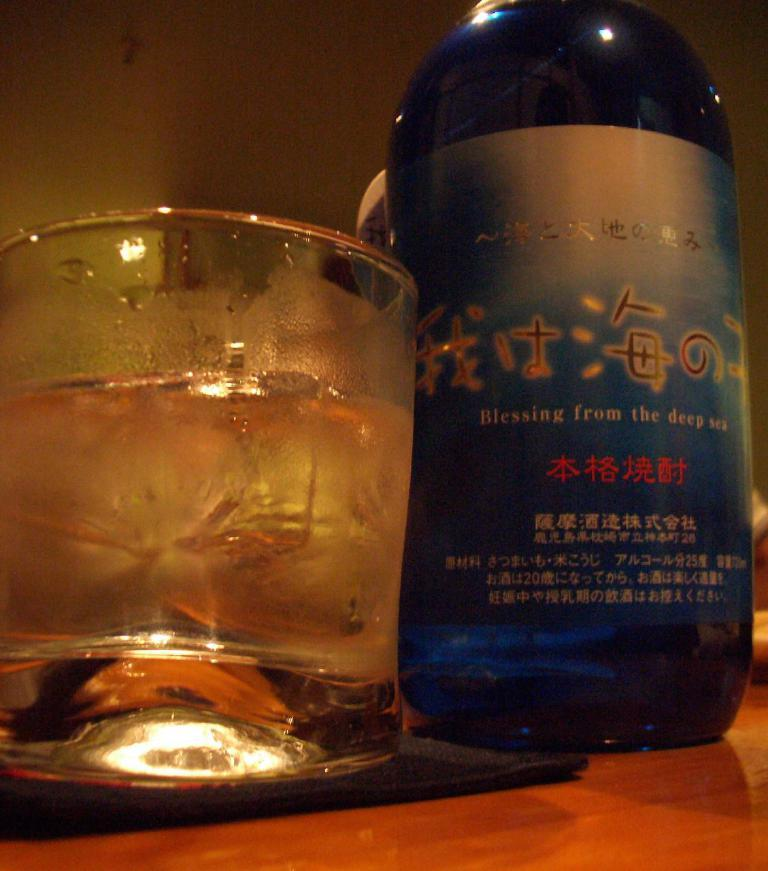<image>
Offer a succinct explanation of the picture presented. A short glass next to a blue bottle with Asian text offering blessings from the deep sea. 